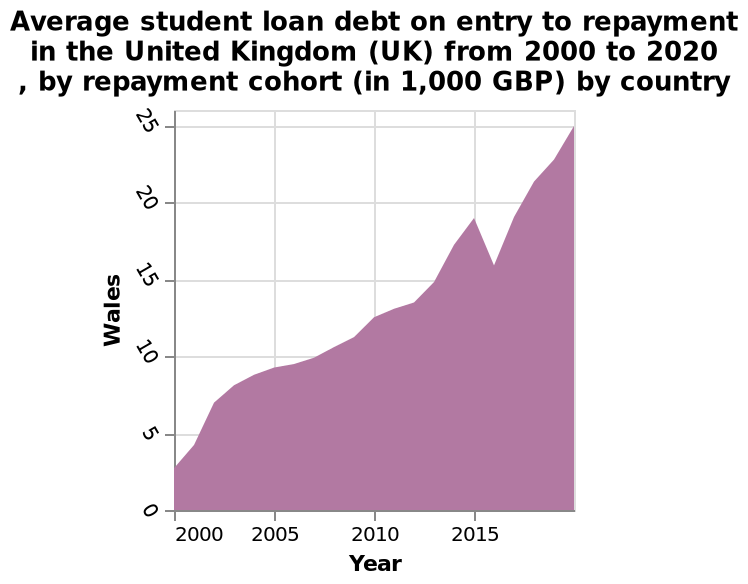<image>
please describe the details of the chart This is a area plot called Average student loan debt on entry to repayment in the United Kingdom (UK) from 2000 to 2020 , by repayment cohort (in 1,000 GBP) by country. The x-axis plots Year while the y-axis shows Wales. Which country does the plot focus on?  The plot focuses on the United Kingdom, specifically on the data related to Wales. How has the number of Wales changed over time? The number of Wales has steadily increased, except for a slight decline in 2016. What is plotted on the y-axis?  The y-axis represents the "Average student loan debt on entry to repayment" in Wales (in 1,000 GBP). 